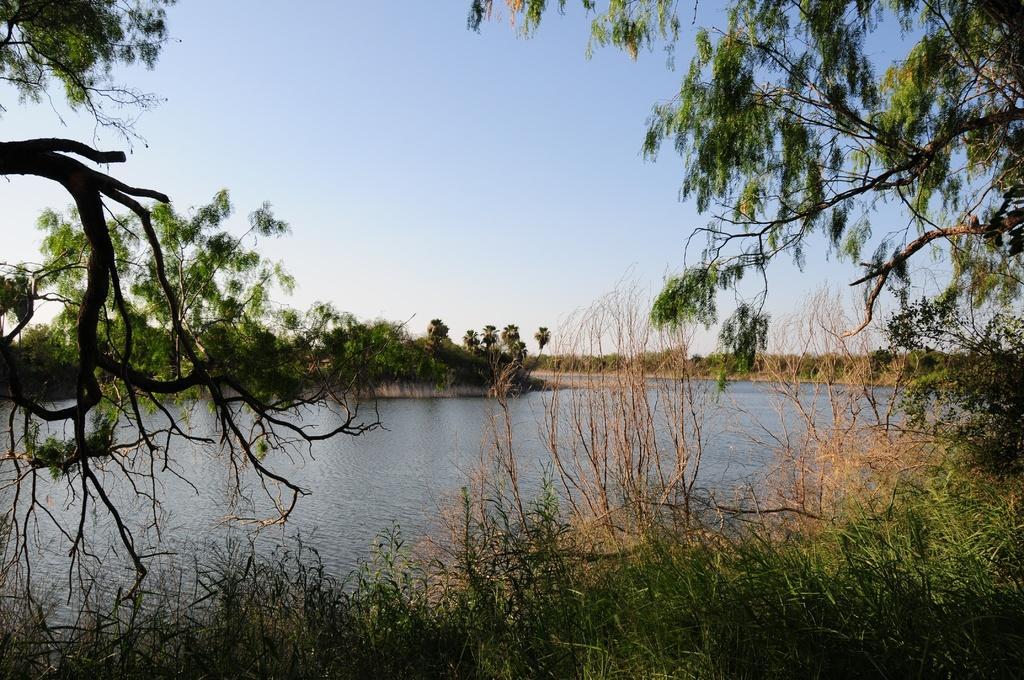Describe this image in one or two sentences. In this picture we can see water and few trees. 